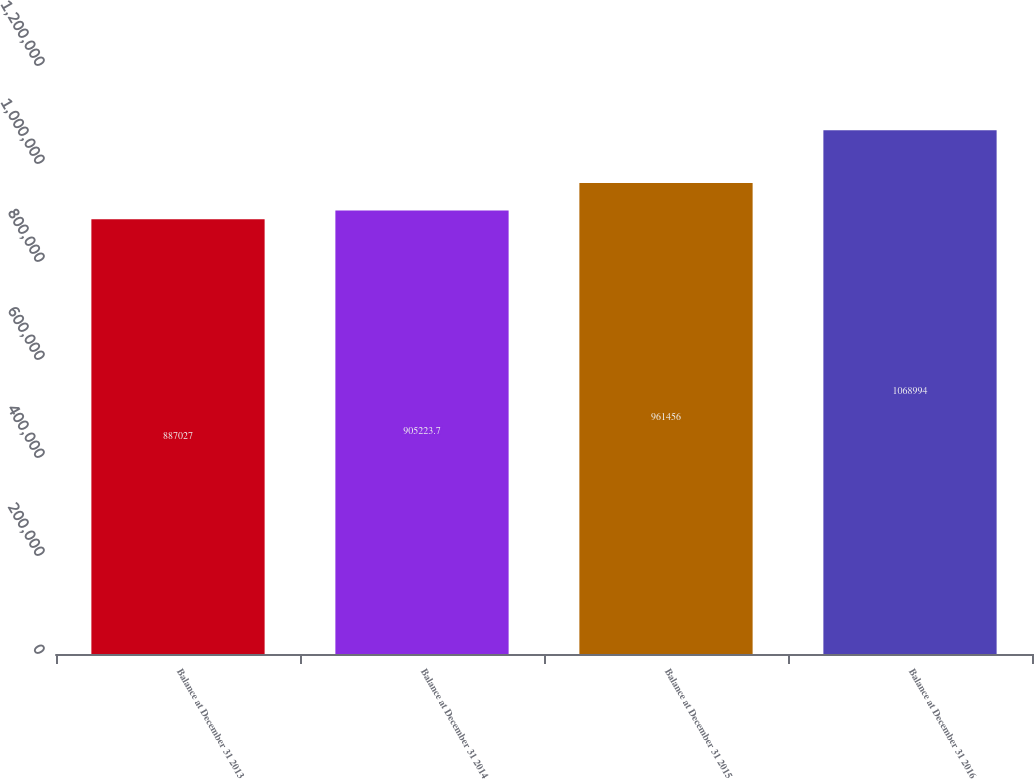Convert chart. <chart><loc_0><loc_0><loc_500><loc_500><bar_chart><fcel>Balance at December 31 2013<fcel>Balance at December 31 2014<fcel>Balance at December 31 2015<fcel>Balance at December 31 2016<nl><fcel>887027<fcel>905224<fcel>961456<fcel>1.06899e+06<nl></chart> 